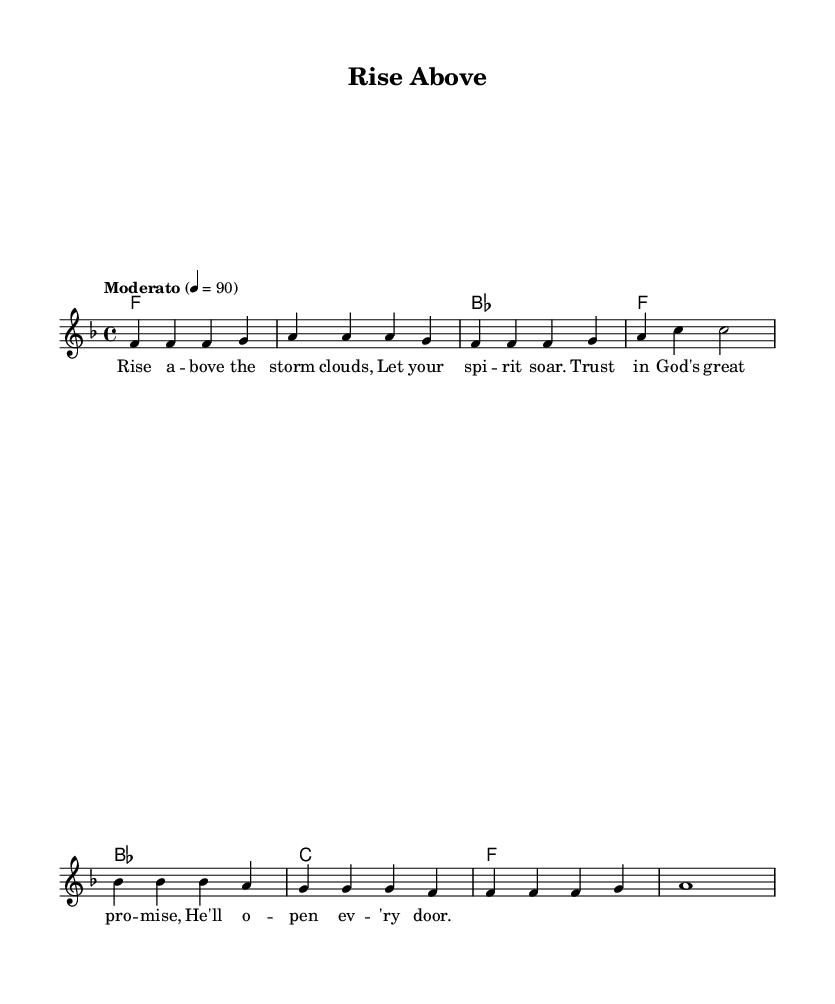What is the key signature of this music? The key signature is F major, which has one flat (B flat) as indicated at the beginning of the first staff line.
Answer: F major What is the time signature of this music? The time signature is 4/4, which means there are four beats in each measure and the quarter note gets one beat, indicated at the beginning of the score.
Answer: 4/4 What is the tempo marking of the piece? The tempo marking is "Moderato," which means a moderate pace. The specific BPM (beats per minute) is not directly shown but is indicated as 4 = 90, meaning the quarter note is played at 90 beats per minute.
Answer: Moderato How many measures are in the melody part? There are 8 measures in the melody part, as indicated by examining the bar lines within the melody notation.
Answer: 8 What is the first lyric sung in this piece? The first lyric sung in the piece is "Rise above the storm clouds," which is directly aligned with the first notes in the melody section of the music sheet.
Answer: Rise above the storm clouds Which chord is played on the first beat of the first measure? The chord played on the first beat of the first measure is F major, as shown in the chord names section where the first chord aligns with the melody’s first note.
Answer: F 